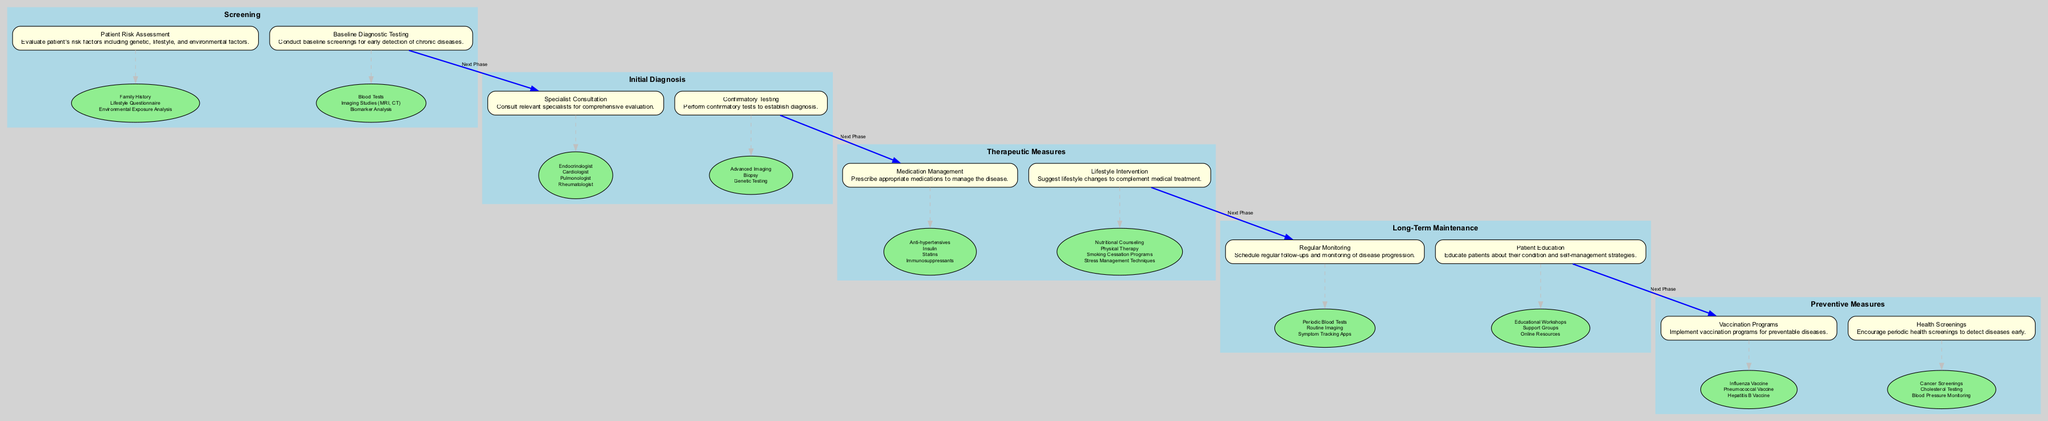What are the two phases before Long-Term Maintenance? The two phases that precede Long-Term Maintenance are Therapeutic Measures and Initial Diagnosis, as indicated by their positions in the sequence.
Answer: Therapeutic Measures, Initial Diagnosis Which tool is used in Patient Risk Assessment? In the Patient Risk Assessment action, one of the tools used is the Lifestyle Questionnaire, which is listed under the tools for that action.
Answer: Lifestyle Questionnaire How many actions are there in the Preventive Measures phase? The Preventive Measures phase consists of two actions: Vaccination Programs and Health Screenings, which can be counted directly from the list of actions in that phase.
Answer: 2 What is the first action in the Initial Diagnosis phase? The first action listed in the Initial Diagnosis phase is Specialist Consultation, which is the first action under that phase in the diagram.
Answer: Specialist Consultation Which phase includes the action "Regular Monitoring"? Regular Monitoring is included in the Long-Term Maintenance phase, as identified by its specific position in the pathway.
Answer: Long-Term Maintenance What is the last tool listed for the action "Medication Management"? The last tool listed for the action Medication Management is Immunosuppressants, as it is the last item in the corresponding list of tools.
Answer: Immunosuppressants Which action is connected to the Confirmatory Testing action? The action connected to Confirmatory Testing is Medication Management following the clinical pathway flow; it represents the next necessary step after confirming a diagnosis.
Answer: Medication Management What action follows Health Screenings in the pathway? Following Health Screenings, the next action in the pathway is Vaccination Programs, according to the sequential connection established between the actions.
Answer: Vaccination Programs 